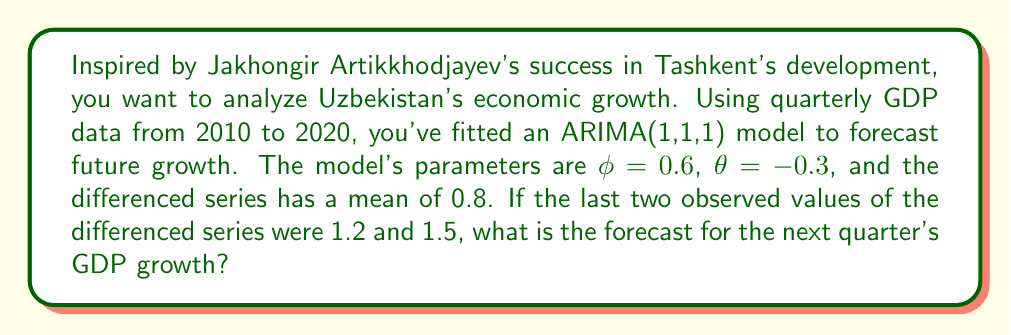Provide a solution to this math problem. Let's approach this step-by-step:

1) The ARIMA(1,1,1) model can be written as:

   $$(1 - \phi B)(1 - B)y_t = (1 + \theta B)\varepsilon_t + c$$

   where $B$ is the backshift operator, $c$ is the drift term, and $\varepsilon_t$ is white noise.

2) For forecasting, we use the following equation:

   $$\hat{y}_{T+1} = y_T + \phi(y_T - y_{T-1}) + \theta\varepsilon_T + c$$

3) We're given:
   - $\phi = 0.6$
   - $\theta = -0.3$
   - The mean of the differenced series is 0.8, which is our $c$
   - The last two observed values of the differenced series are 1.2 and 1.5

4) We need to find $\varepsilon_T$. We can do this using:

   $$\varepsilon_T = y_T - y_{T-1} - \phi(y_{T-1} - y_{T-2}) - c$$

   $$\varepsilon_T = 1.5 - 1.2 - 0.6(1.2 - y_{T-2}) - 0.8$$

   We don't know $y_{T-2}$, but we can approximate by assuming it's close to the mean, so:

   $$\varepsilon_T \approx 1.5 - 1.2 - 0.6(1.2 - 0.8) - 0.8 = -0.74$$

5) Now we can forecast:

   $$\hat{y}_{T+1} = 1.5 + 0.6(1.5 - 1.2) + (-0.3)(-0.74) + 0.8$$

6) Calculating:

   $$\hat{y}_{T+1} = 1.5 + 0.18 + 0.222 + 0.8 = 2.702$$
Answer: The forecast for the next quarter's GDP growth is approximately 2.702. 